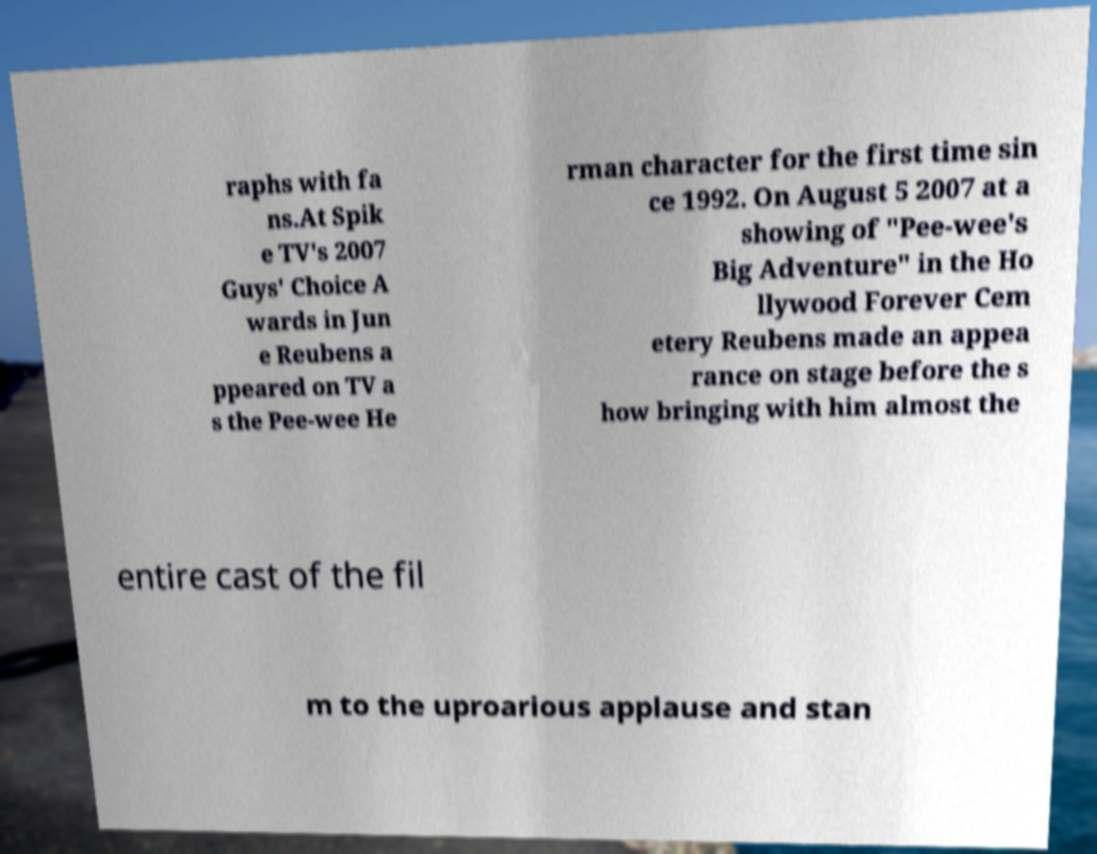Can you accurately transcribe the text from the provided image for me? raphs with fa ns.At Spik e TV's 2007 Guys' Choice A wards in Jun e Reubens a ppeared on TV a s the Pee-wee He rman character for the first time sin ce 1992. On August 5 2007 at a showing of "Pee-wee's Big Adventure" in the Ho llywood Forever Cem etery Reubens made an appea rance on stage before the s how bringing with him almost the entire cast of the fil m to the uproarious applause and stan 